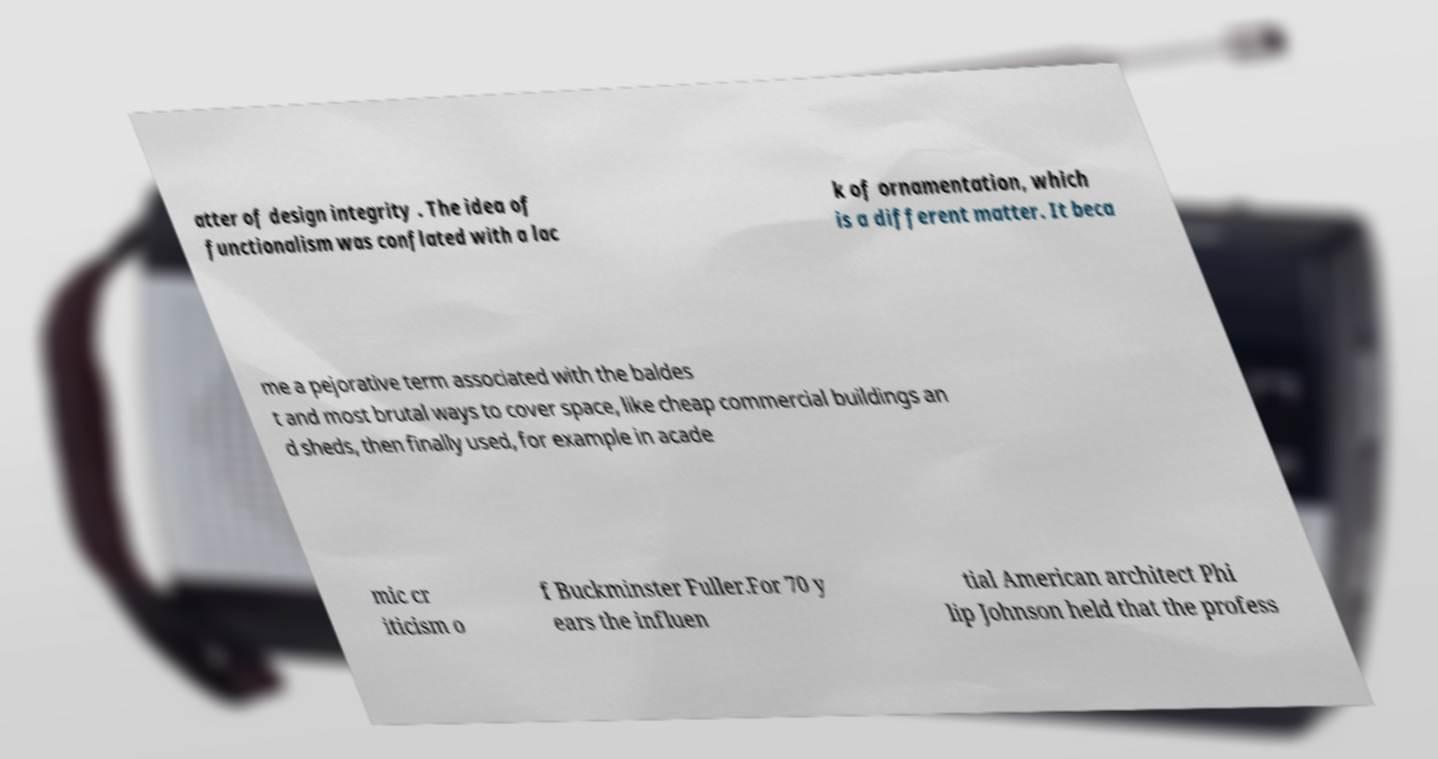Please read and relay the text visible in this image. What does it say? atter of design integrity . The idea of functionalism was conflated with a lac k of ornamentation, which is a different matter. It beca me a pejorative term associated with the baldes t and most brutal ways to cover space, like cheap commercial buildings an d sheds, then finally used, for example in acade mic cr iticism o f Buckminster Fuller.For 70 y ears the influen tial American architect Phi lip Johnson held that the profess 